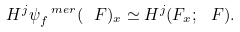Convert formula to latex. <formula><loc_0><loc_0><loc_500><loc_500>H ^ { j } \psi _ { f } ^ { \ m e r } ( \ F ) _ { x } \simeq H ^ { j } ( F _ { x } ; \ F ) .</formula> 